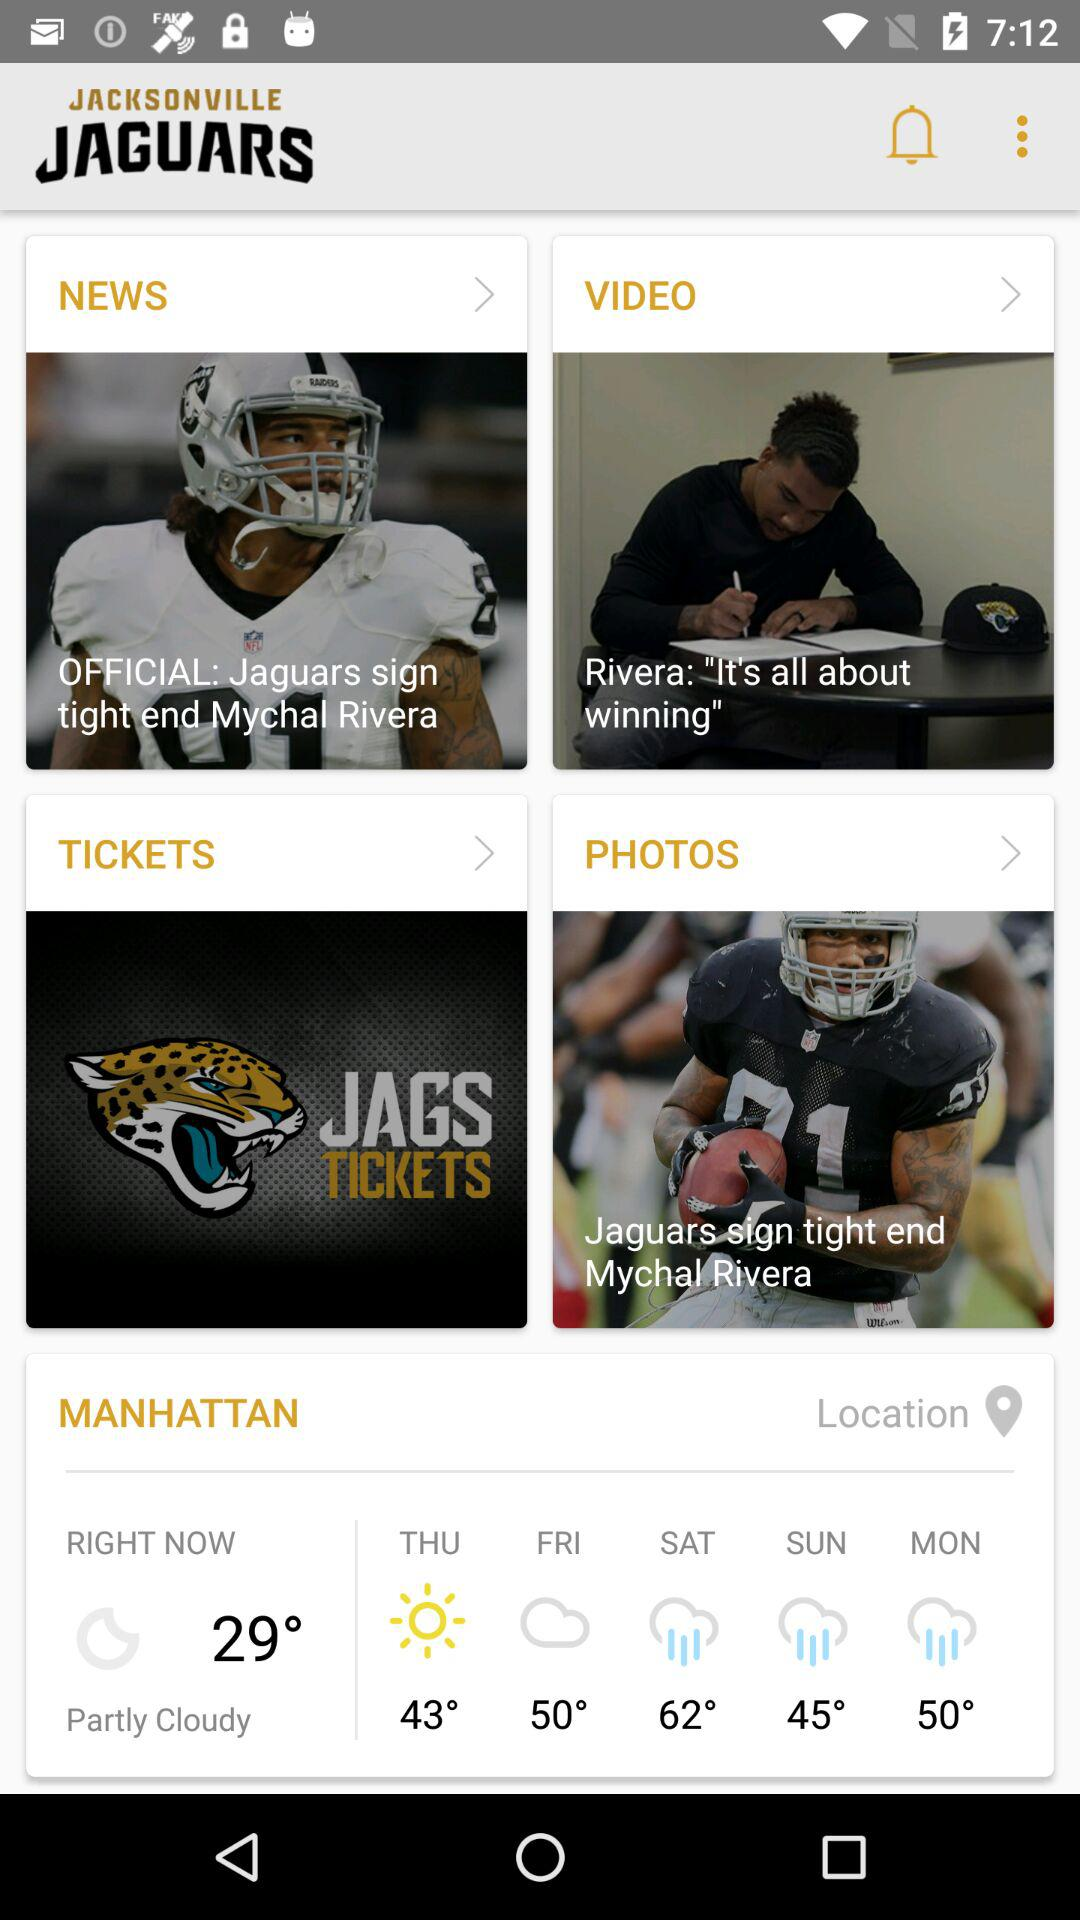What is the temperature on Monday? On Monday, the temperature is 50°. 